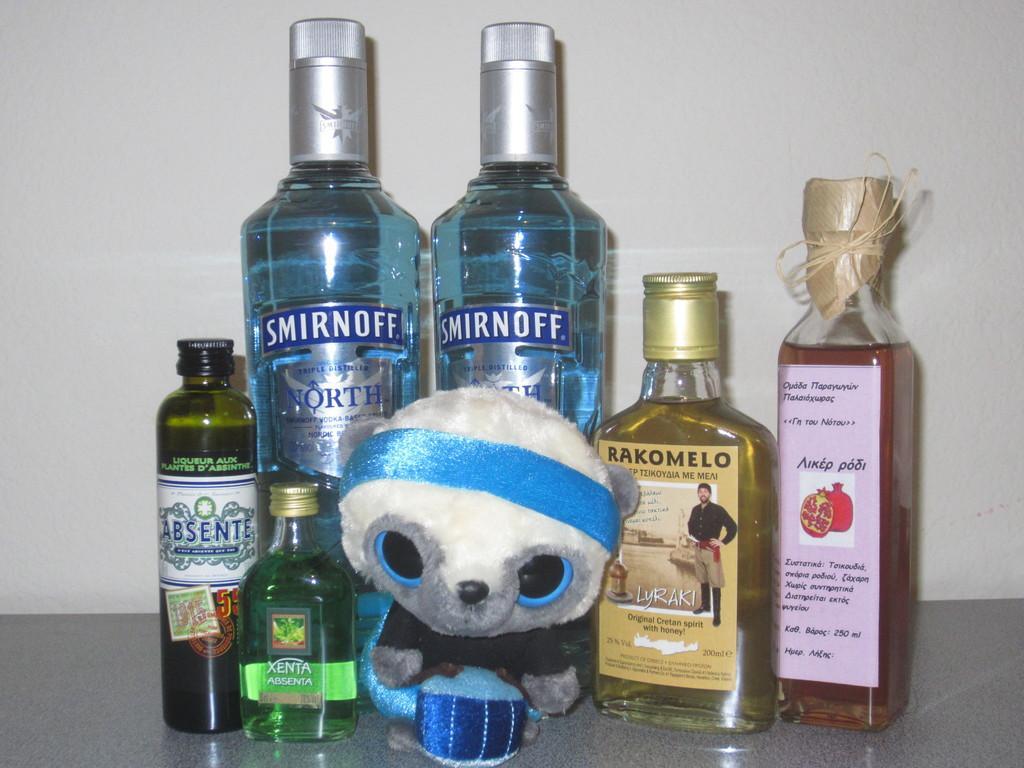In one or two sentences, can you explain what this image depicts? This picture shows bunch of bottles of wine and a toy 